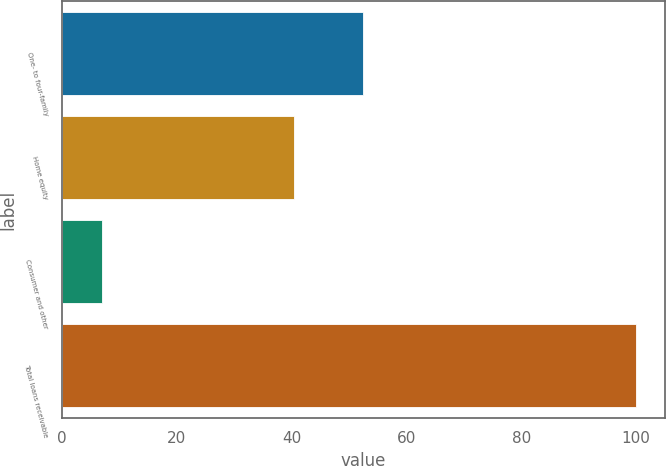Convert chart. <chart><loc_0><loc_0><loc_500><loc_500><bar_chart><fcel>One- to four-family<fcel>Home equity<fcel>Consumer and other<fcel>Total loans receivable<nl><fcel>52.5<fcel>40.4<fcel>7.1<fcel>100<nl></chart> 